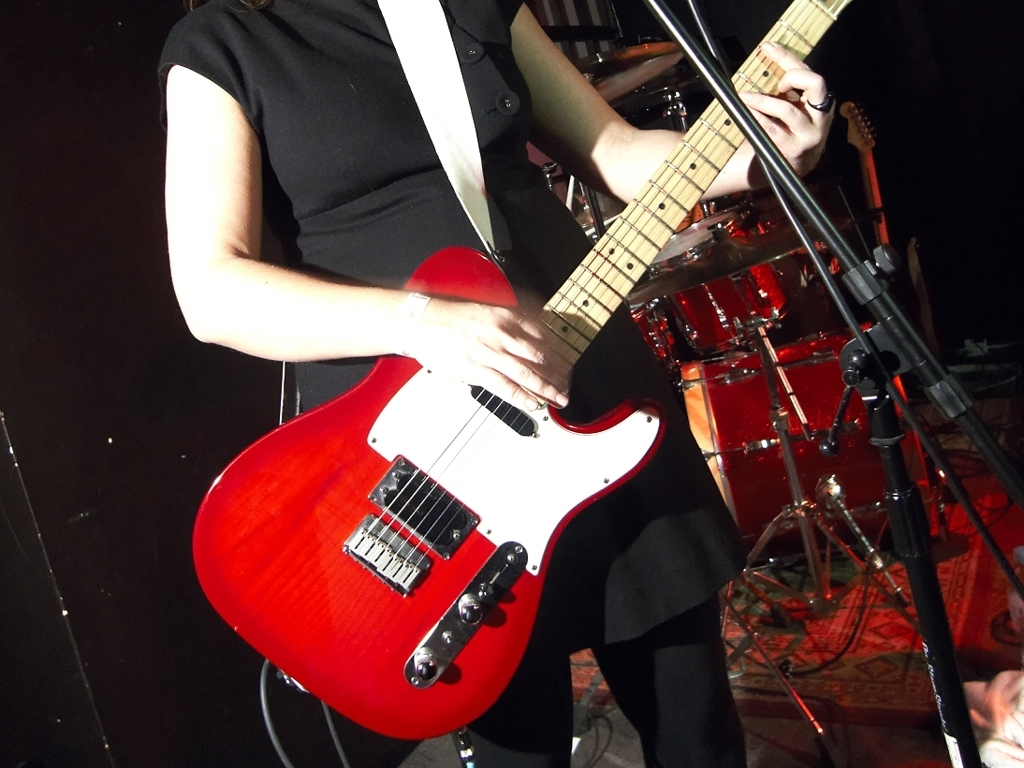Is there strong lighting in the image? Yes, the image features strong, direct lighting that creates vivid highlights, particularly on the guitar and the performer's hands, indicating a spotlight effect that's often used in live performance settings. 